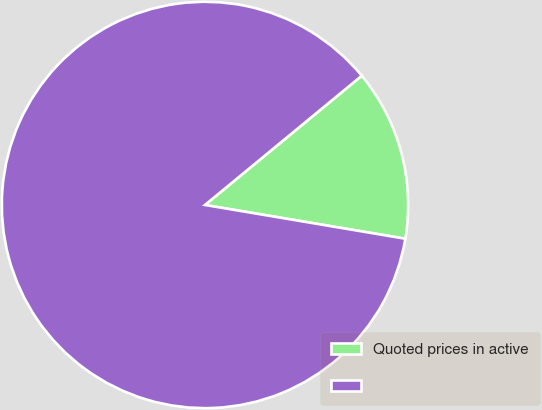<chart> <loc_0><loc_0><loc_500><loc_500><pie_chart><fcel>Quoted prices in active<fcel>Unnamed: 1<nl><fcel>13.63%<fcel>86.37%<nl></chart> 